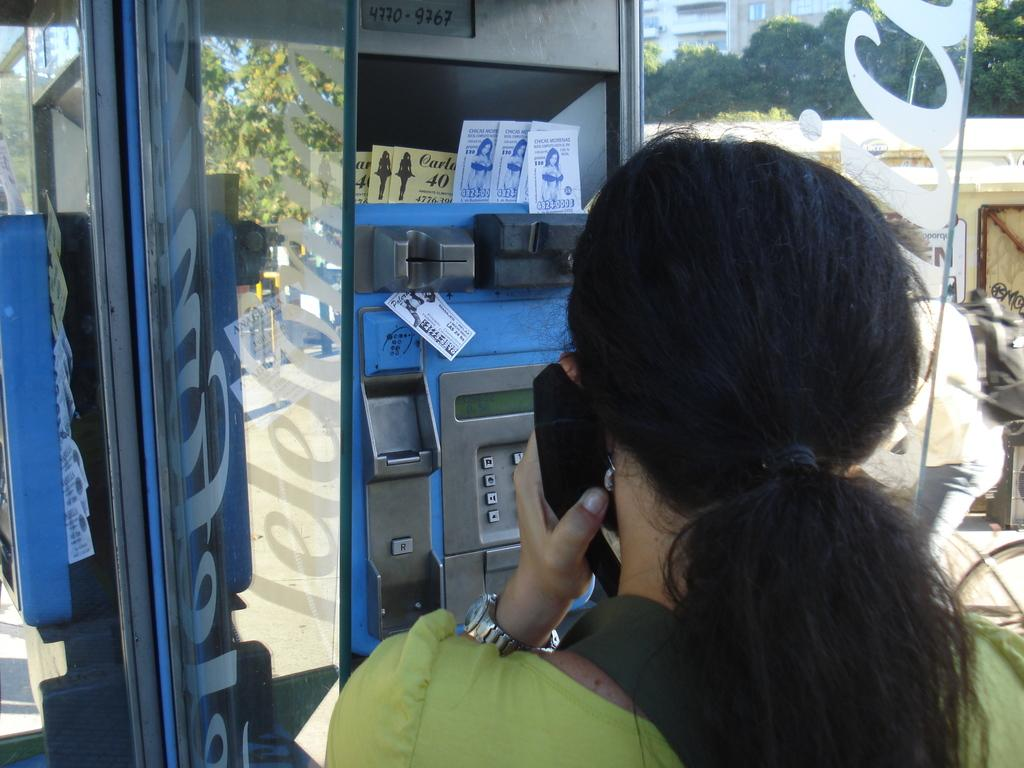What is the main subject of the image? There is a woman in the image. What is the woman doing in the image? The woman is standing and speaking in the image. What structure can be seen in the image? There is a telephone booth in the image. What can be seen in the right corner of the image? There are trees and a building in the right corner of the image. What type of jewel is the woman wearing in the image? There is no mention of a jewel in the image, so it cannot be determined if the woman is wearing one. 